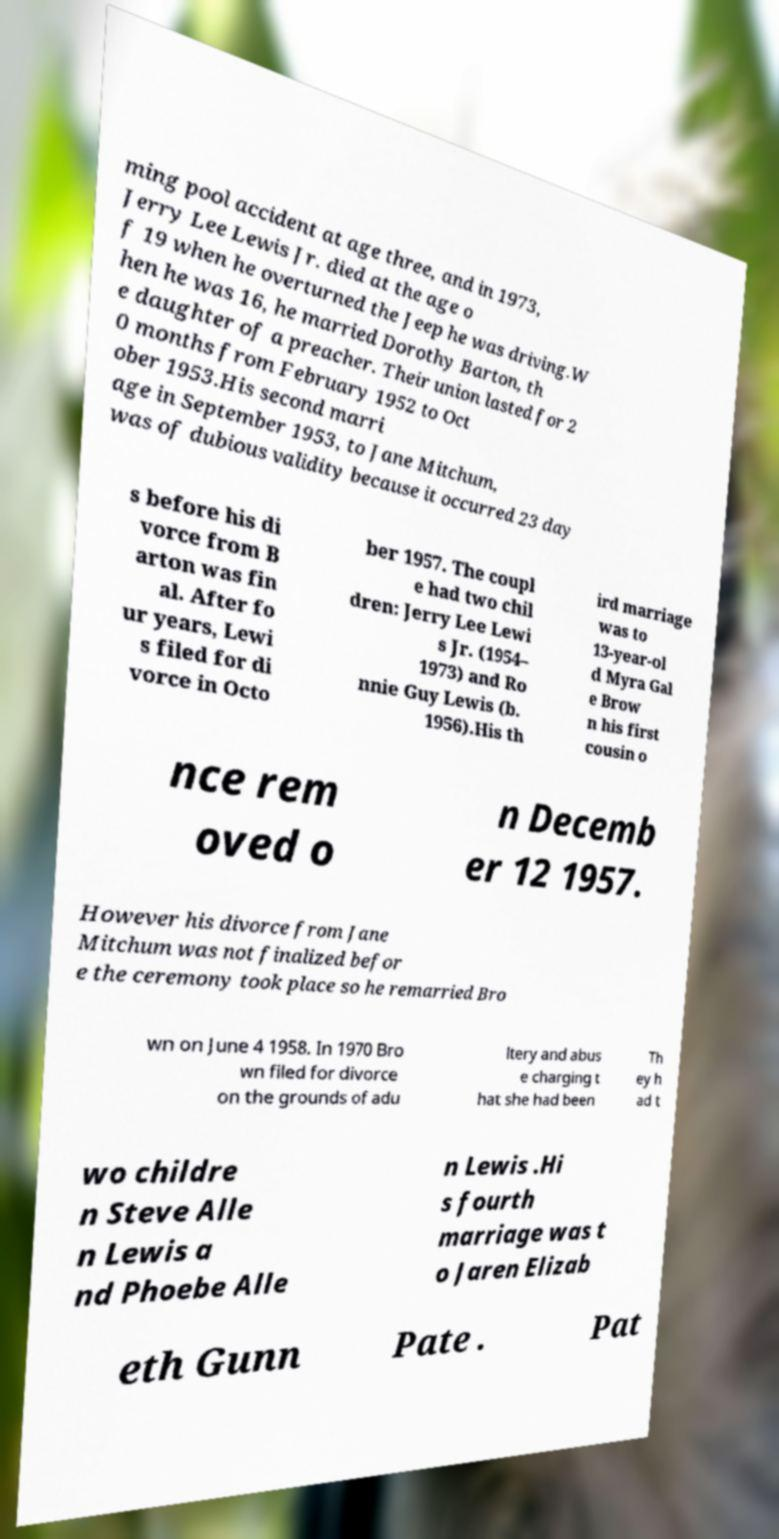For documentation purposes, I need the text within this image transcribed. Could you provide that? ming pool accident at age three, and in 1973, Jerry Lee Lewis Jr. died at the age o f 19 when he overturned the Jeep he was driving.W hen he was 16, he married Dorothy Barton, th e daughter of a preacher. Their union lasted for 2 0 months from February 1952 to Oct ober 1953.His second marri age in September 1953, to Jane Mitchum, was of dubious validity because it occurred 23 day s before his di vorce from B arton was fin al. After fo ur years, Lewi s filed for di vorce in Octo ber 1957. The coupl e had two chil dren: Jerry Lee Lewi s Jr. (1954– 1973) and Ro nnie Guy Lewis (b. 1956).His th ird marriage was to 13-year-ol d Myra Gal e Brow n his first cousin o nce rem oved o n Decemb er 12 1957. However his divorce from Jane Mitchum was not finalized befor e the ceremony took place so he remarried Bro wn on June 4 1958. In 1970 Bro wn filed for divorce on the grounds of adu ltery and abus e charging t hat she had been Th ey h ad t wo childre n Steve Alle n Lewis a nd Phoebe Alle n Lewis .Hi s fourth marriage was t o Jaren Elizab eth Gunn Pate . Pat 